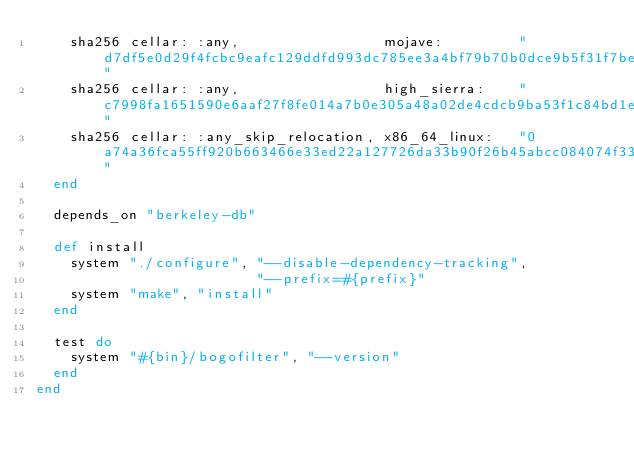Convert code to text. <code><loc_0><loc_0><loc_500><loc_500><_Ruby_>    sha256 cellar: :any,                 mojave:         "d7df5e0d29f4fcbc9eafc129ddfd993dc785ee3a4bf79b70b0dce9b5f31f7be4"
    sha256 cellar: :any,                 high_sierra:    "c7998fa1651590e6aaf27f8fe014a7b0e305a48a02de4cdcb9ba53f1c84bd1e7"
    sha256 cellar: :any_skip_relocation, x86_64_linux:   "0a74a36fca55ff920b663466e33ed22a127726da33b90f26b45abcc084074f33"
  end

  depends_on "berkeley-db"

  def install
    system "./configure", "--disable-dependency-tracking",
                          "--prefix=#{prefix}"
    system "make", "install"
  end

  test do
    system "#{bin}/bogofilter", "--version"
  end
end
</code> 